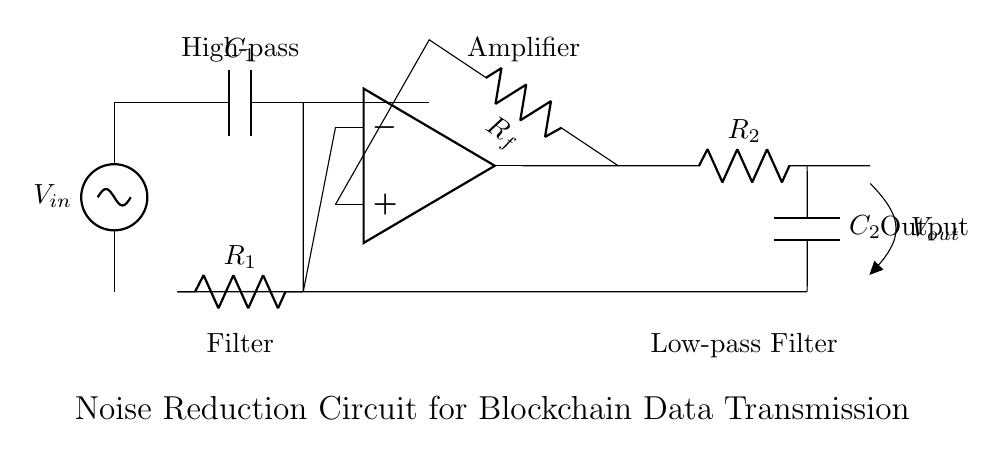What is the input voltage of the circuit? The input voltage is labeled as \( V_{in} \), which is the source in the circuit diagram.
Answer: \( V_{in} \) What is the purpose of the component labeled \( C_1 \)? The component \( C_1 \) is a capacitor that forms part of the high-pass filter, allowing higher frequency signals to pass while blocking lower frequencies.
Answer: High-pass Filter What type of amplifier is used in this circuit? The circuit uses an operational amplifier indicated by the op amp symbol.
Answer: Operational Amplifier What is the role of the feedback resistor \( R_f \)? The feedback resistor \( R_f \) connects the output of the operational amplifier back to its non-inverting input, helping to stabilize the gain of the amplifier.
Answer: Stabilizes gain How does the low-pass filter affect the output signal? The low-pass filter, consisting of \( R_2 \) and \( C_2 \), attenuates high-frequency noise from the output signal, allowing only lower frequency components to pass through.
Answer: Attenuates high frequency What is the output voltage of the circuit indicated? The output voltage is labeled \( V_{out} \) in the circuit diagram, representing the resulting voltage after processing by the noise reduction circuit.
Answer: \( V_{out} \) Why is there both a high-pass and low-pass filter in this circuit design? The combination of a high-pass and low-pass filter allows the circuit to selectively filter out unwanted noise and improve the integrity of the blockchain data transmission by isolating the desired signal frequencies.
Answer: Signal Integrity 